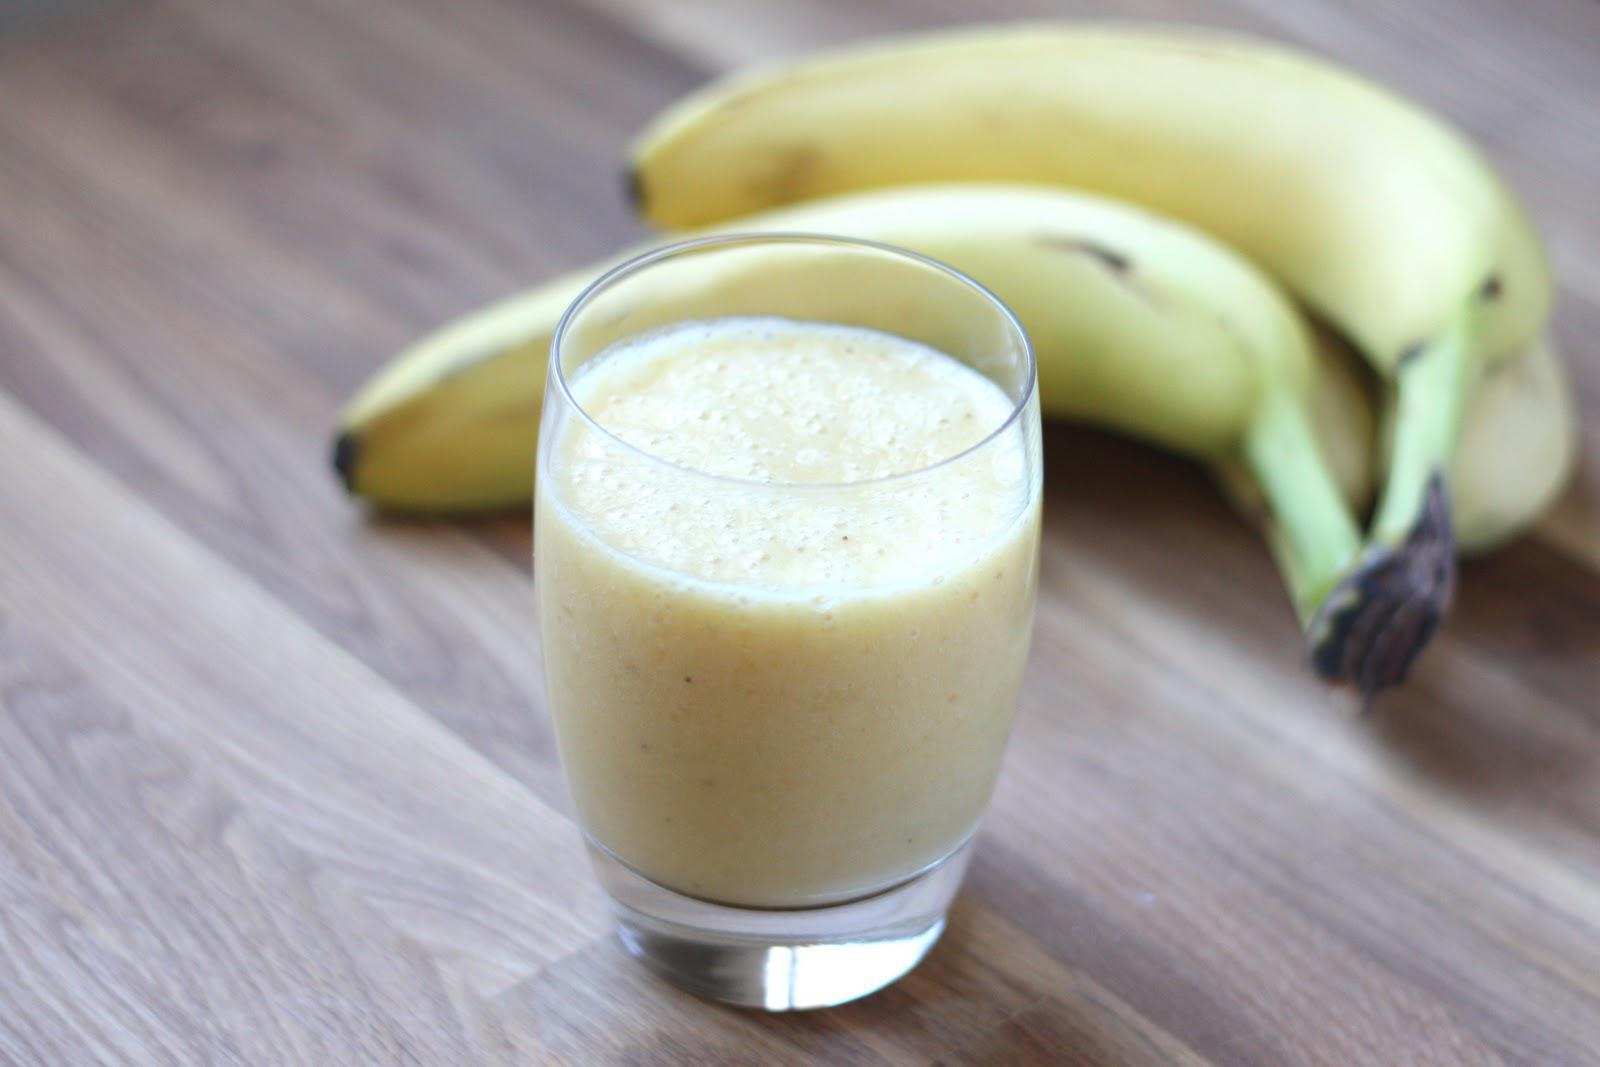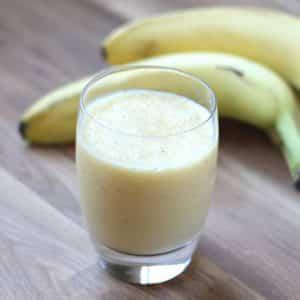The first image is the image on the left, the second image is the image on the right. For the images displayed, is the sentence "One of the drinks has a straw in it." factually correct? Answer yes or no. No. The first image is the image on the left, the second image is the image on the right. Evaluate the accuracy of this statement regarding the images: "One glass of creamy beverage has a straw standing in it, and at least one glass of creamy beverage has a wedge of fruit on the rim of the glass.". Is it true? Answer yes or no. No. 